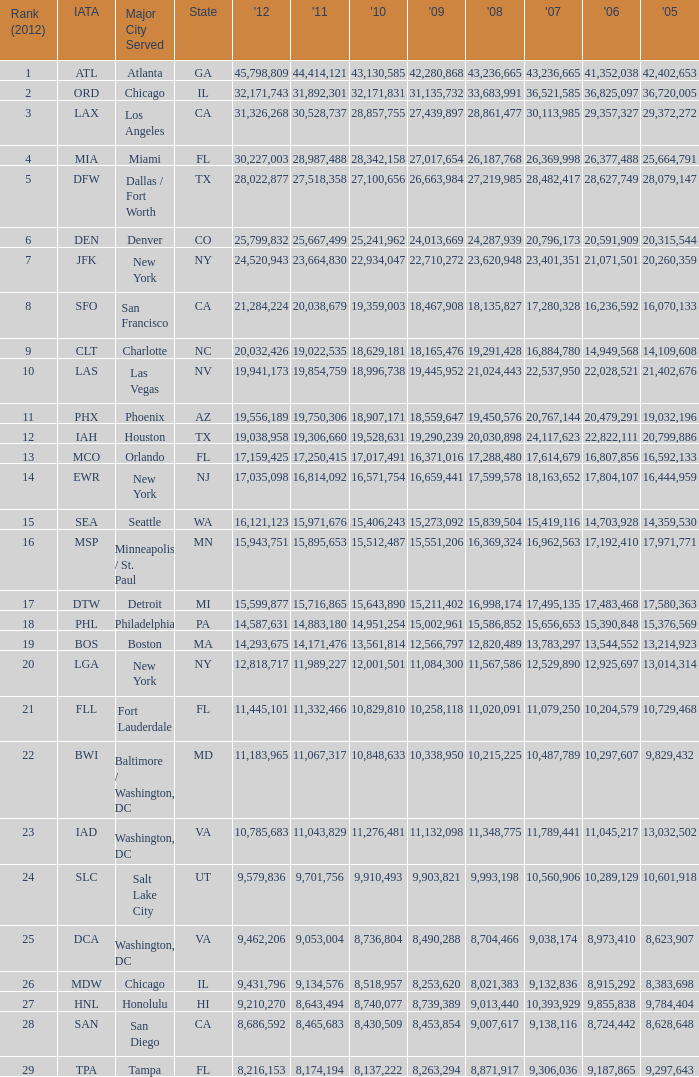When Philadelphia has a 2007 less than 20,796,173 and a 2008 more than 10,215,225, what is the smallest 2009? 15002961.0. 